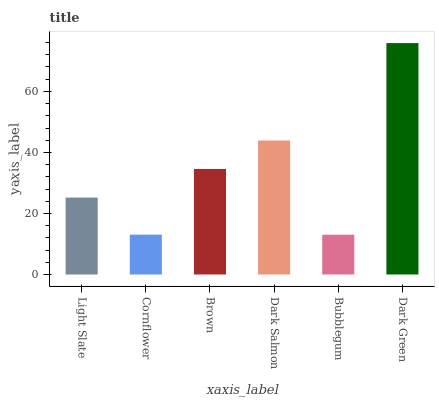Is Bubblegum the minimum?
Answer yes or no. Yes. Is Dark Green the maximum?
Answer yes or no. Yes. Is Cornflower the minimum?
Answer yes or no. No. Is Cornflower the maximum?
Answer yes or no. No. Is Light Slate greater than Cornflower?
Answer yes or no. Yes. Is Cornflower less than Light Slate?
Answer yes or no. Yes. Is Cornflower greater than Light Slate?
Answer yes or no. No. Is Light Slate less than Cornflower?
Answer yes or no. No. Is Brown the high median?
Answer yes or no. Yes. Is Light Slate the low median?
Answer yes or no. Yes. Is Light Slate the high median?
Answer yes or no. No. Is Brown the low median?
Answer yes or no. No. 